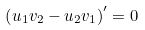<formula> <loc_0><loc_0><loc_500><loc_500>\left ( u _ { 1 } v _ { 2 } - u _ { 2 } v _ { 1 } \right ) ^ { \prime } = 0</formula> 